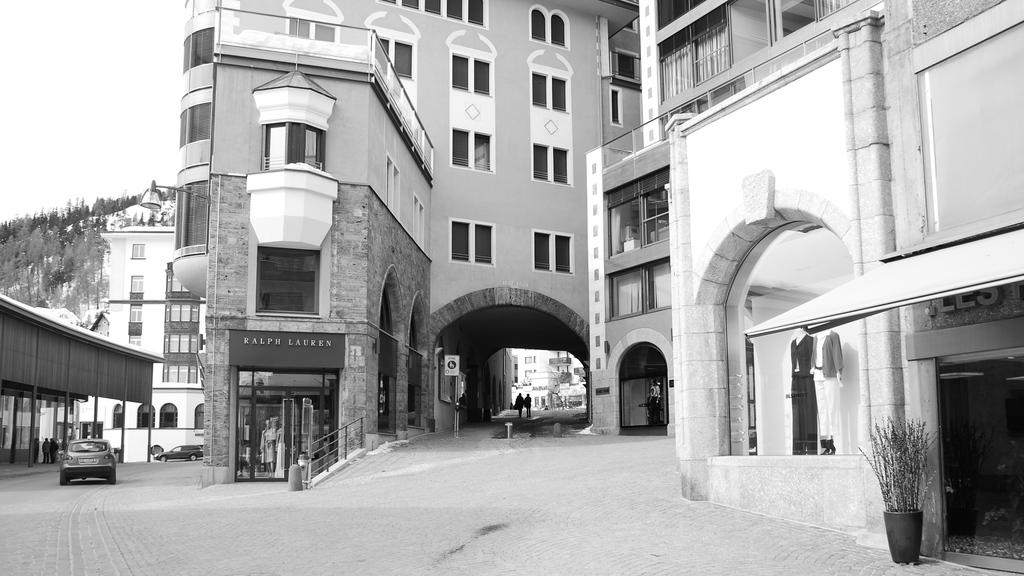What type of structures can be seen in the image? There are buildings in the image. Are there any living beings present in the image? Yes, there are people in the image. What mode of transportation is visible in the image? There is a car in the image. Can you identify any natural elements in the image? Yes, there is a plant in the image. Where is the volleyball being played in the image? There is no volleyball present in the image. What type of bait is being used to catch fish in the image? There is no fishing or bait present in the image. 